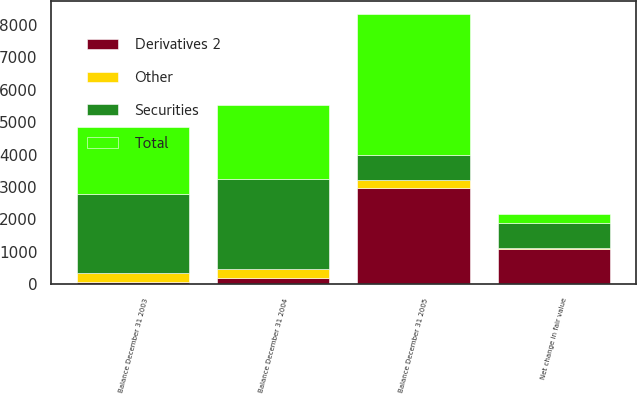Convert chart to OTSL. <chart><loc_0><loc_0><loc_500><loc_500><stacked_bar_chart><ecel><fcel>Balance December 31 2003<fcel>Net change in fair value<fcel>Balance December 31 2004<fcel>Balance December 31 2005<nl><fcel>Derivatives 2<fcel>70<fcel>1088<fcel>197<fcel>2978<nl><fcel>Total<fcel>2094<fcel>294<fcel>2279<fcel>4338<nl><fcel>Other<fcel>270<fcel>18<fcel>288<fcel>240<nl><fcel>Securities<fcel>2434<fcel>776<fcel>2764<fcel>776<nl></chart> 